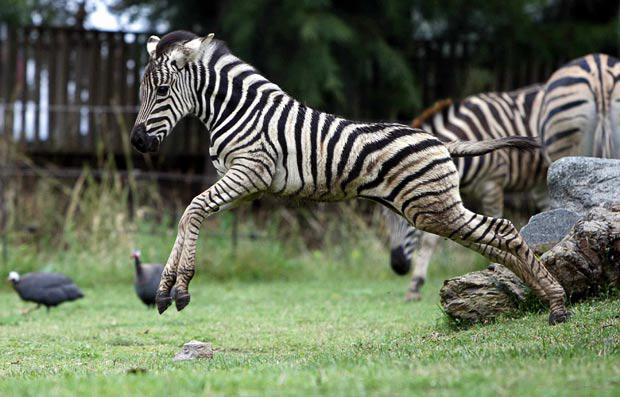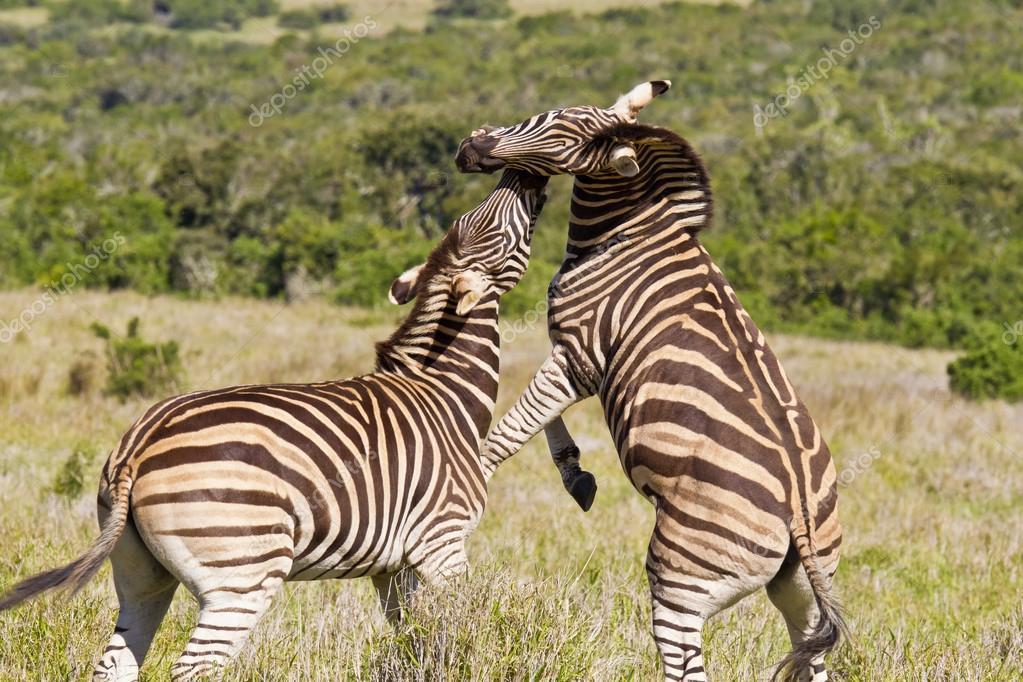The first image is the image on the left, the second image is the image on the right. Analyze the images presented: Is the assertion "One of the animals in the image on the right only has two feet on the ground." valid? Answer yes or no. Yes. The first image is the image on the left, the second image is the image on the right. Evaluate the accuracy of this statement regarding the images: "The left image shows a young zebra bounding leftward, with multiple feet off the ground, and the right image features two zebras fact-to-face.". Is it true? Answer yes or no. Yes. 